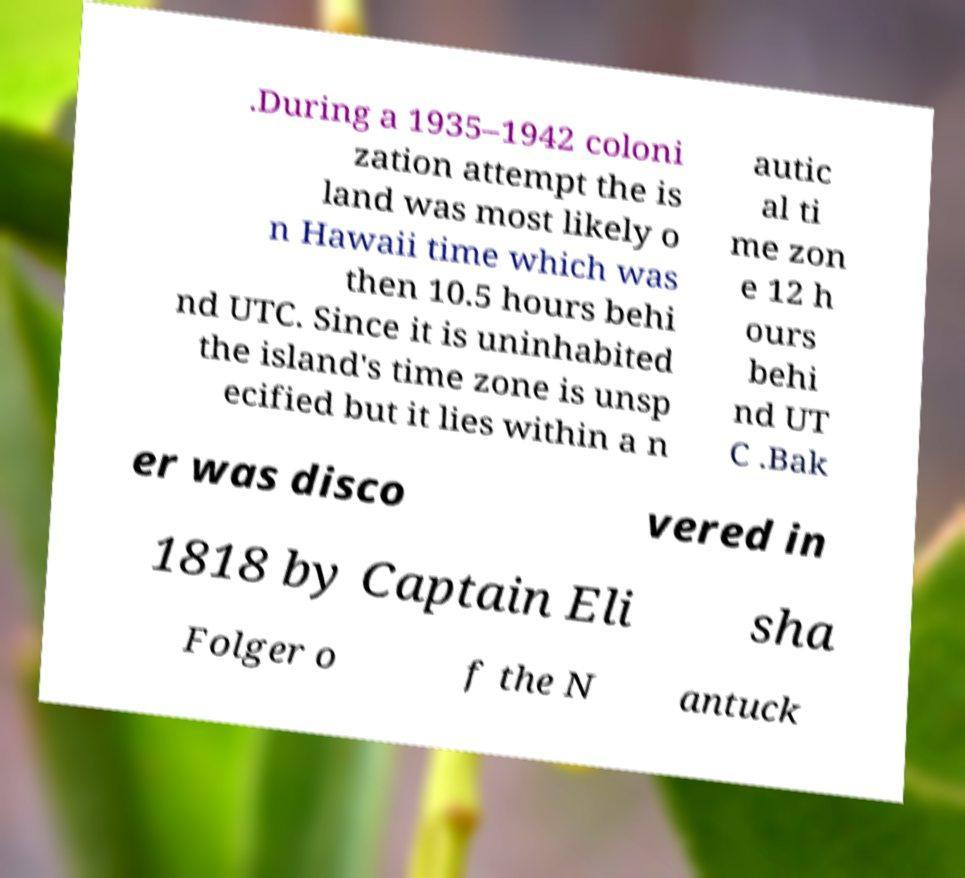Please read and relay the text visible in this image. What does it say? .During a 1935–1942 coloni zation attempt the is land was most likely o n Hawaii time which was then 10.5 hours behi nd UTC. Since it is uninhabited the island's time zone is unsp ecified but it lies within a n autic al ti me zon e 12 h ours behi nd UT C .Bak er was disco vered in 1818 by Captain Eli sha Folger o f the N antuck 